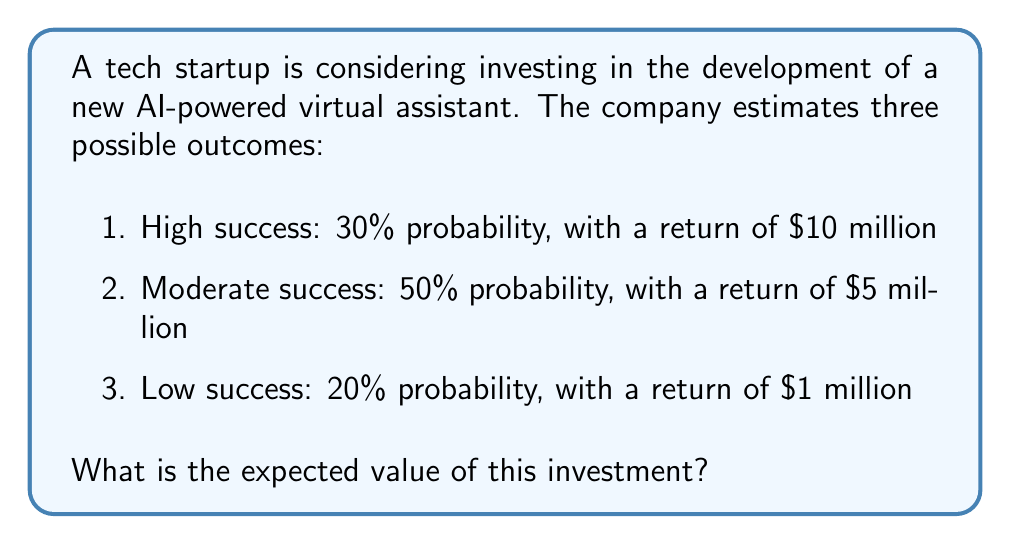Teach me how to tackle this problem. To solve this problem, we'll use the concept of expected value from probability theory. The expected value is calculated by multiplying each possible outcome by its probability and then summing these products.

Let's define our variables:
$p_1 = 0.30$ (probability of high success)
$p_2 = 0.50$ (probability of moderate success)
$p_3 = 0.20$ (probability of low success)
$v_1 = 10$ (value of high success in millions)
$v_2 = 5$ (value of moderate success in millions)
$v_3 = 1$ (value of low success in millions)

The formula for expected value is:

$$ E = \sum_{i=1}^n p_i v_i $$

Where $E$ is the expected value, $p_i$ is the probability of each outcome, and $v_i$ is the value of each outcome.

Substituting our values:

$$ E = (p_1 \times v_1) + (p_2 \times v_2) + (p_3 \times v_3) $$
$$ E = (0.30 \times 10) + (0.50 \times 5) + (0.20 \times 1) $$
$$ E = 3 + 2.5 + 0.2 $$
$$ E = 5.7 $$

Therefore, the expected value of the investment is $5.7 million.
Answer: $5.7 million 